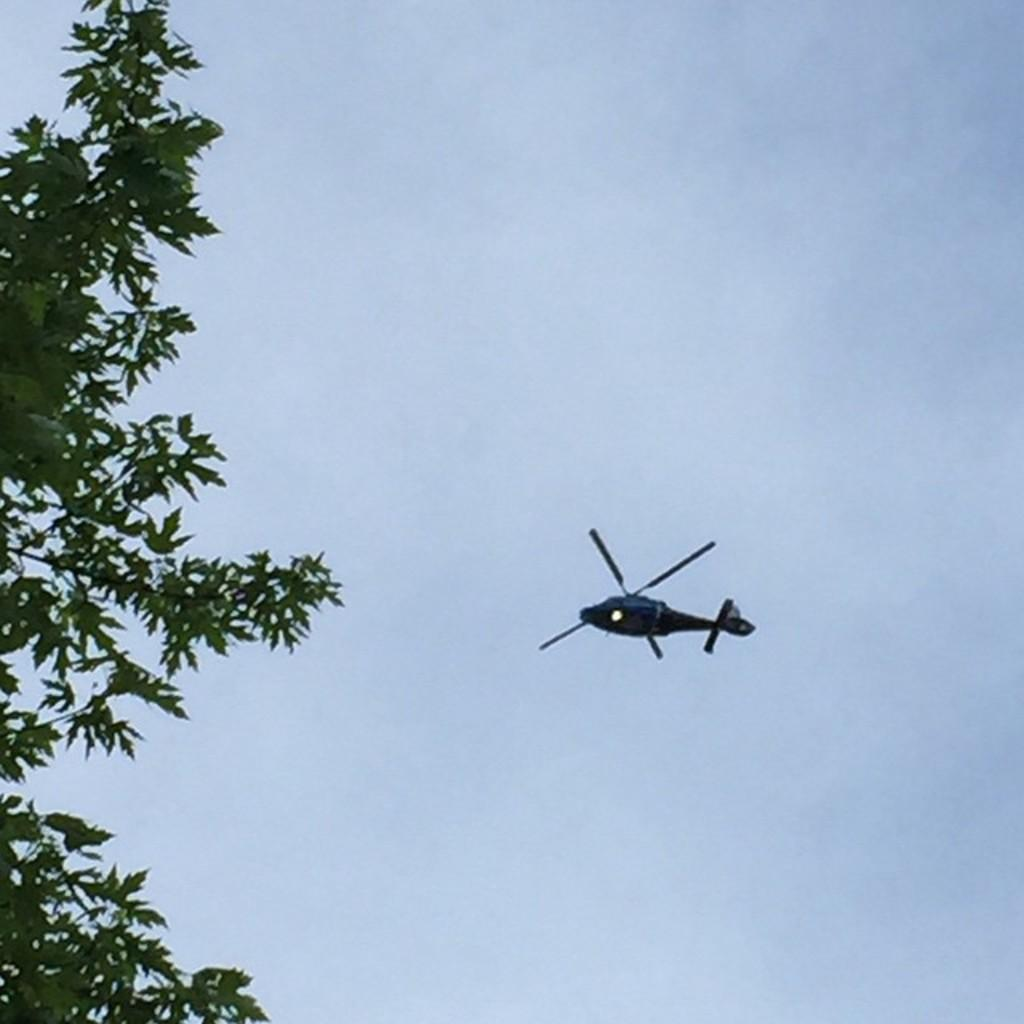What is the main subject of the image? The main subject of the image is a helicopter. In which direction is the helicopter flying? The helicopter is flying towards the left side. What can be seen on the left side of the image? Few leaves are visible on the left side. What is visible in the background of the image? The sky is visible in the background of the image. What type of art can be seen on the helicopter's tail in the image? There is no art visible on the helicopter's tail in the image. What is the mass of the helicopter in the image? The mass of the helicopter cannot be determined from the image alone. 